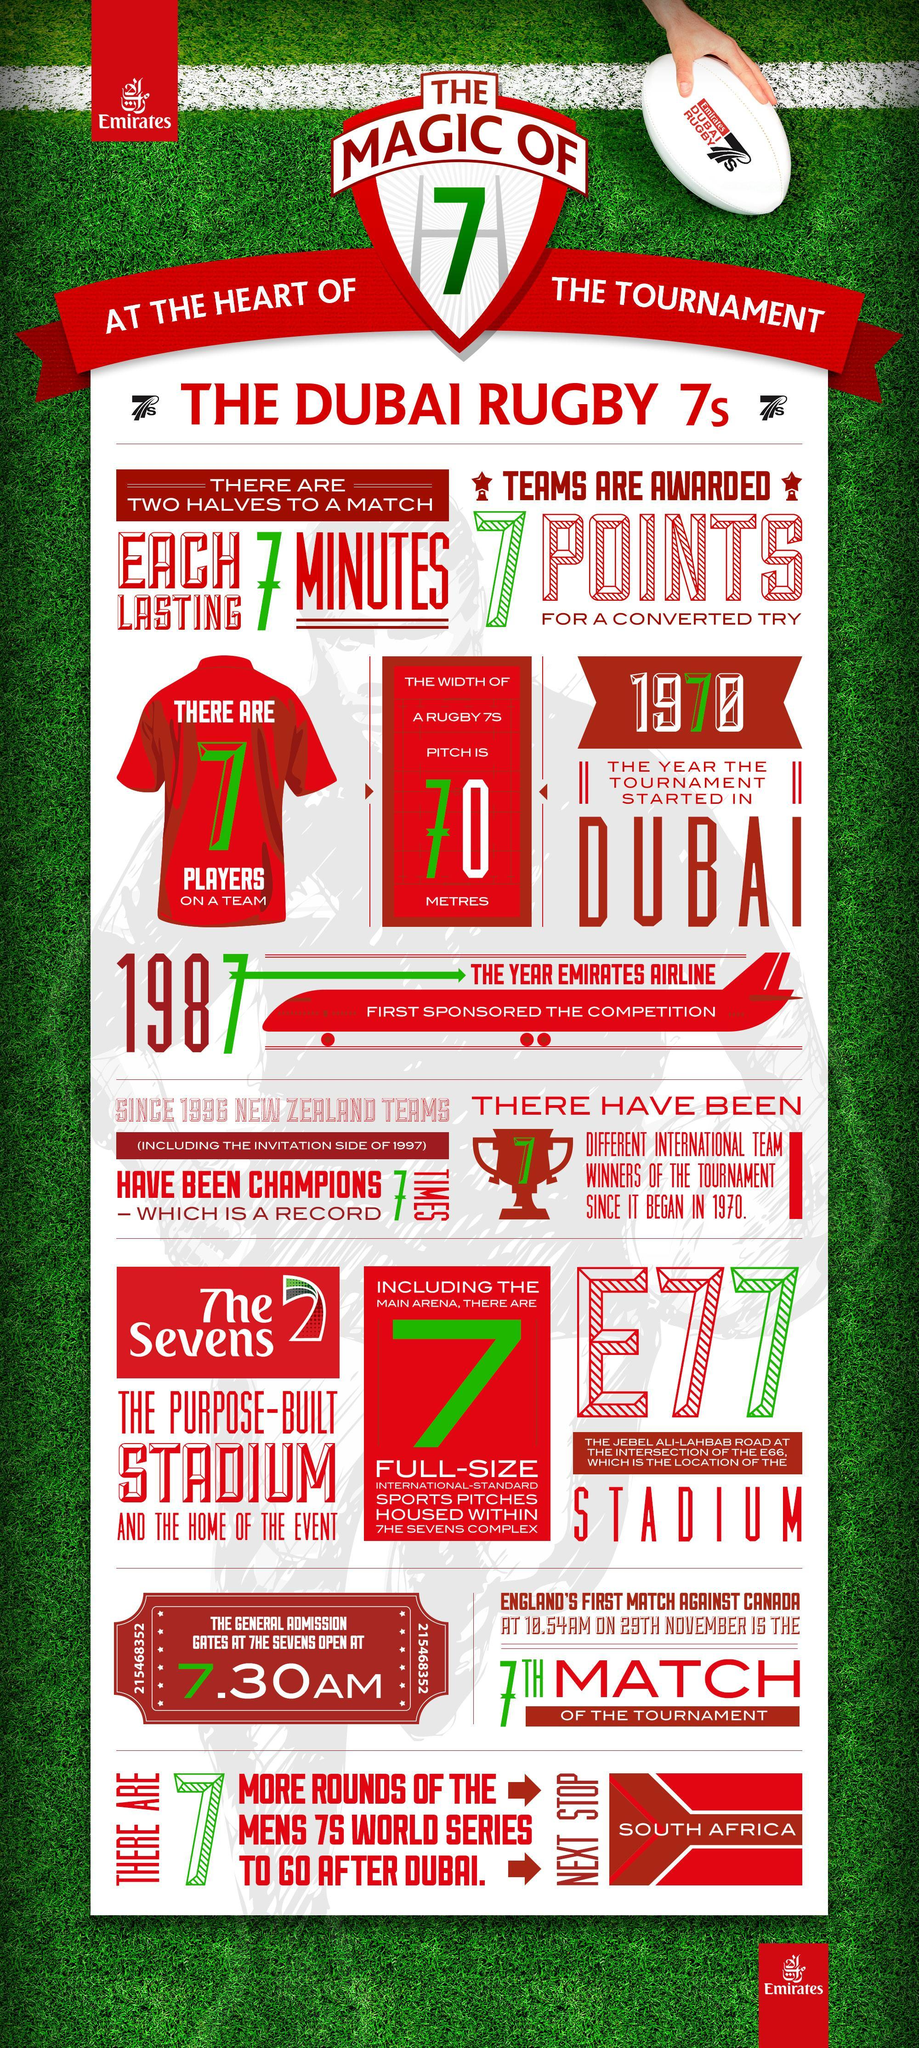Which year the emirates airlines first sponsored the Dubai Rugby 7s tournament?
Answer the question with a short phrase. 1987 In which stadium, the Dubai Rugby 7s tournament is played? The Sevens When was the Dubai Sevens founded? 1970 